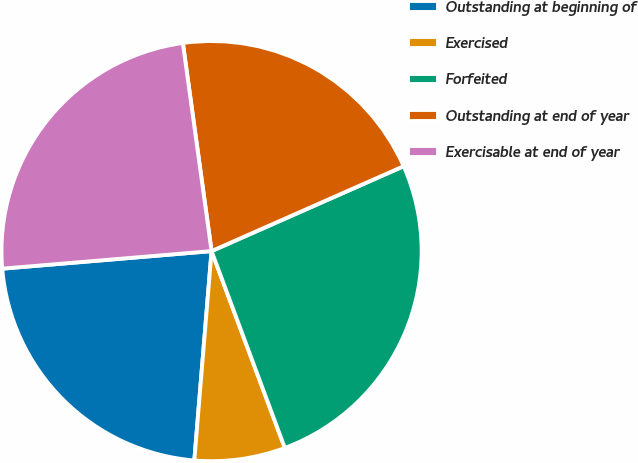Convert chart to OTSL. <chart><loc_0><loc_0><loc_500><loc_500><pie_chart><fcel>Outstanding at beginning of<fcel>Exercised<fcel>Forfeited<fcel>Outstanding at end of year<fcel>Exercisable at end of year<nl><fcel>22.36%<fcel>6.98%<fcel>25.95%<fcel>20.56%<fcel>24.15%<nl></chart> 